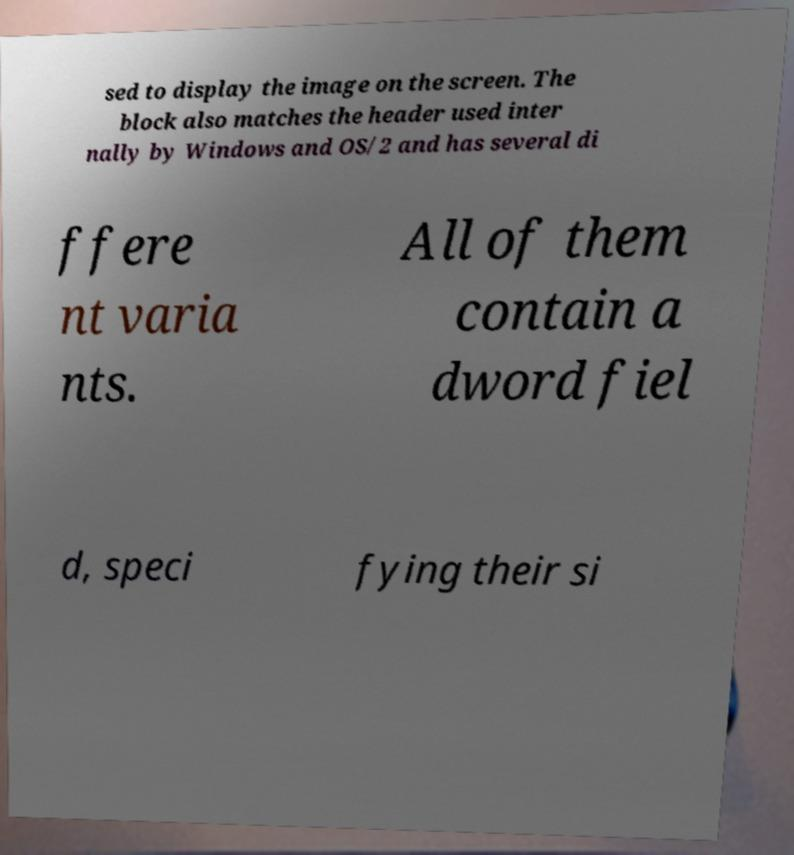Please read and relay the text visible in this image. What does it say? sed to display the image on the screen. The block also matches the header used inter nally by Windows and OS/2 and has several di ffere nt varia nts. All of them contain a dword fiel d, speci fying their si 